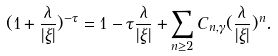<formula> <loc_0><loc_0><loc_500><loc_500>( 1 + \frac { \lambda } { | \xi | } ) ^ { - \tau } = 1 - \tau \frac { \lambda } { | \xi | } + \sum _ { n \geq 2 } C _ { n , \gamma } ( \frac { \lambda } { | \xi | } ) ^ { n } .</formula> 